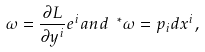Convert formula to latex. <formula><loc_0><loc_0><loc_500><loc_500>\omega = \frac { \partial L } { \partial y ^ { i } } e ^ { i } a n d \ ^ { \ast } \omega = p _ { i } d x ^ { i } ,</formula> 